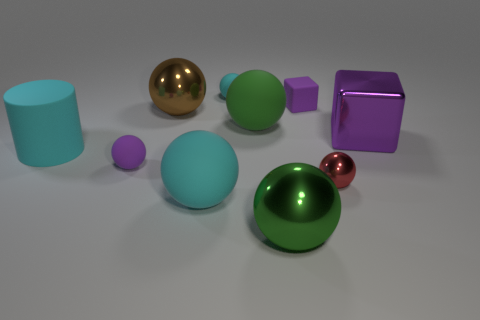Is the number of small purple balls in front of the cylinder greater than the number of things to the right of the big purple thing?
Your answer should be compact. Yes. There is a cylinder that is the same size as the brown object; what is its color?
Your answer should be compact. Cyan. Is there a tiny ball that has the same color as the cylinder?
Offer a very short reply. Yes. Do the large shiny sphere that is in front of the green matte ball and the big matte sphere on the right side of the big cyan rubber sphere have the same color?
Offer a terse response. Yes. What material is the purple cube left of the big purple thing?
Give a very brief answer. Rubber. The tiny sphere that is the same material as the brown object is what color?
Ensure brevity in your answer.  Red. What number of cyan rubber objects have the same size as the purple rubber cube?
Your answer should be very brief. 1. Does the purple object that is on the right side of the purple rubber block have the same size as the rubber cylinder?
Your response must be concise. Yes. What shape is the object that is both in front of the large block and on the right side of the large green metallic ball?
Provide a short and direct response. Sphere. There is a small metallic object; are there any tiny purple rubber balls behind it?
Provide a short and direct response. Yes. 